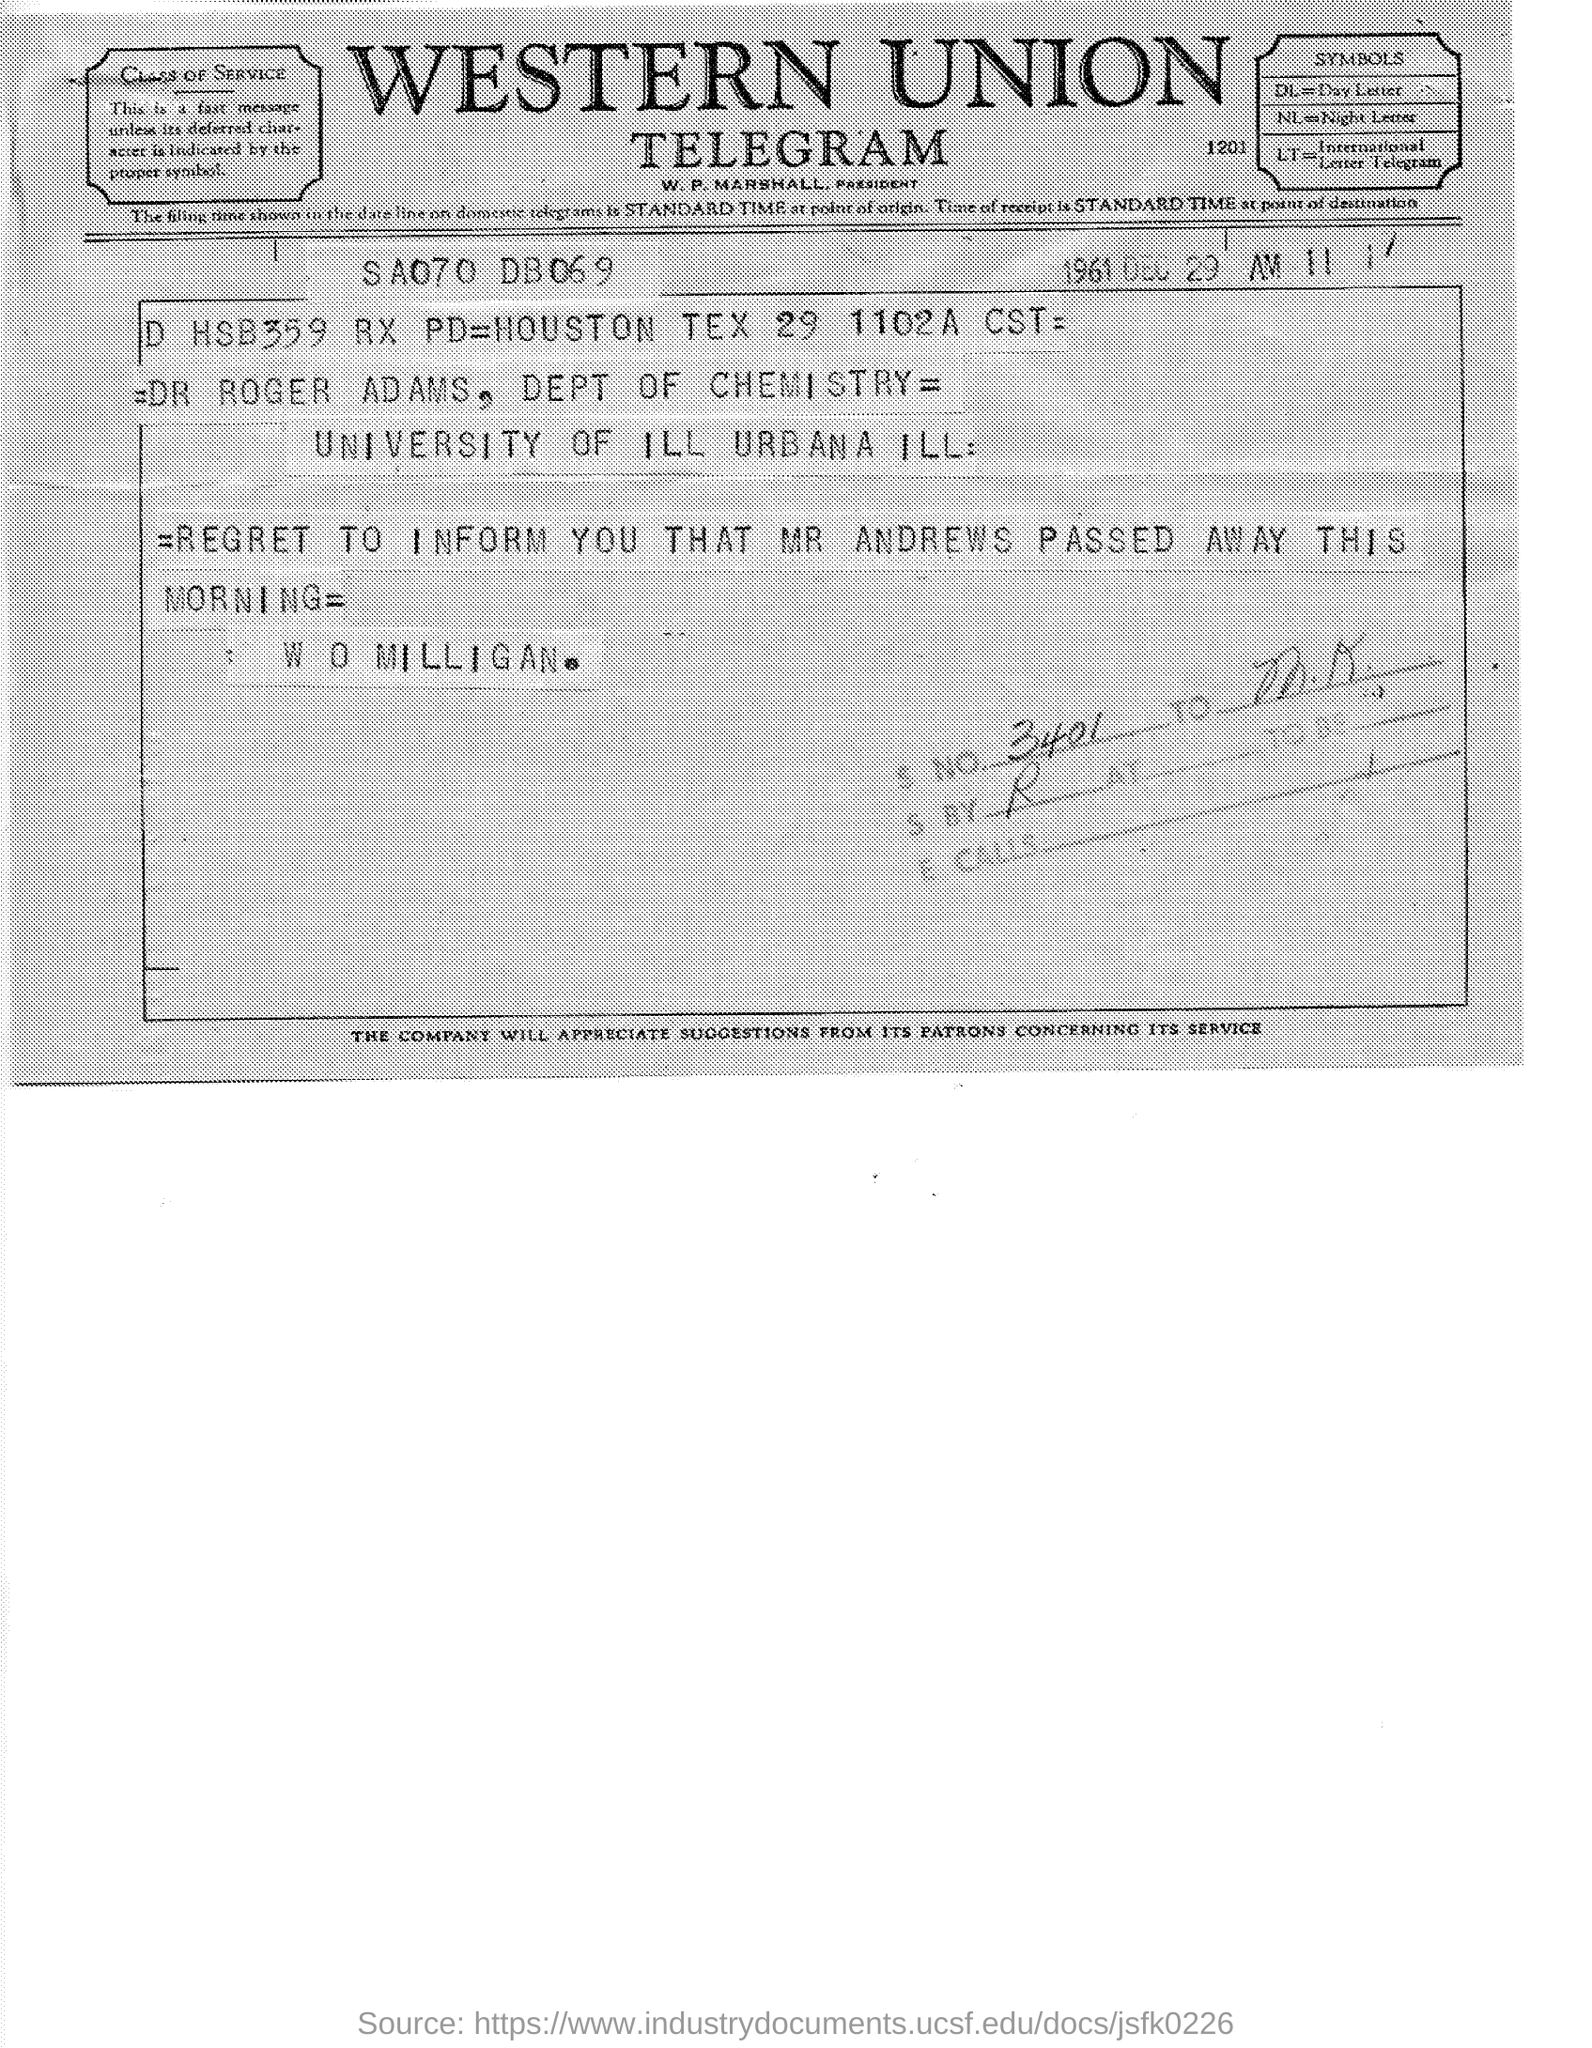Specify some key components in this picture. Night Letter" is an abbreviation that stands for "NL. It has been announced that MR Andrews has passed away this morning, as mentioned in the telegram. DL stands for 'day letter'. The union in question is referred to as Western Union. The date mentioned in the given telegram is December 29, 1961. 